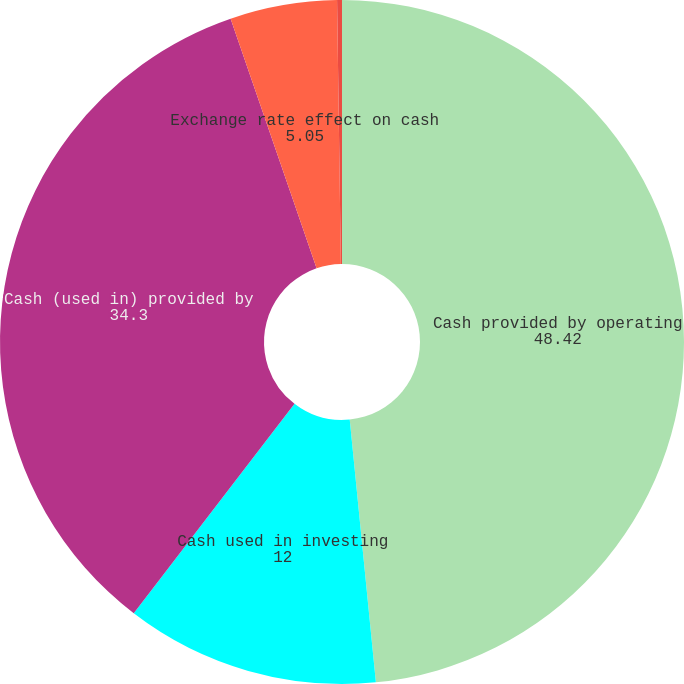Convert chart. <chart><loc_0><loc_0><loc_500><loc_500><pie_chart><fcel>Cash provided by operating<fcel>Cash used in investing<fcel>Cash (used in) provided by<fcel>Exchange rate effect on cash<fcel>(Decrease) increase in cash<nl><fcel>48.42%<fcel>12.0%<fcel>34.3%<fcel>5.05%<fcel>0.23%<nl></chart> 